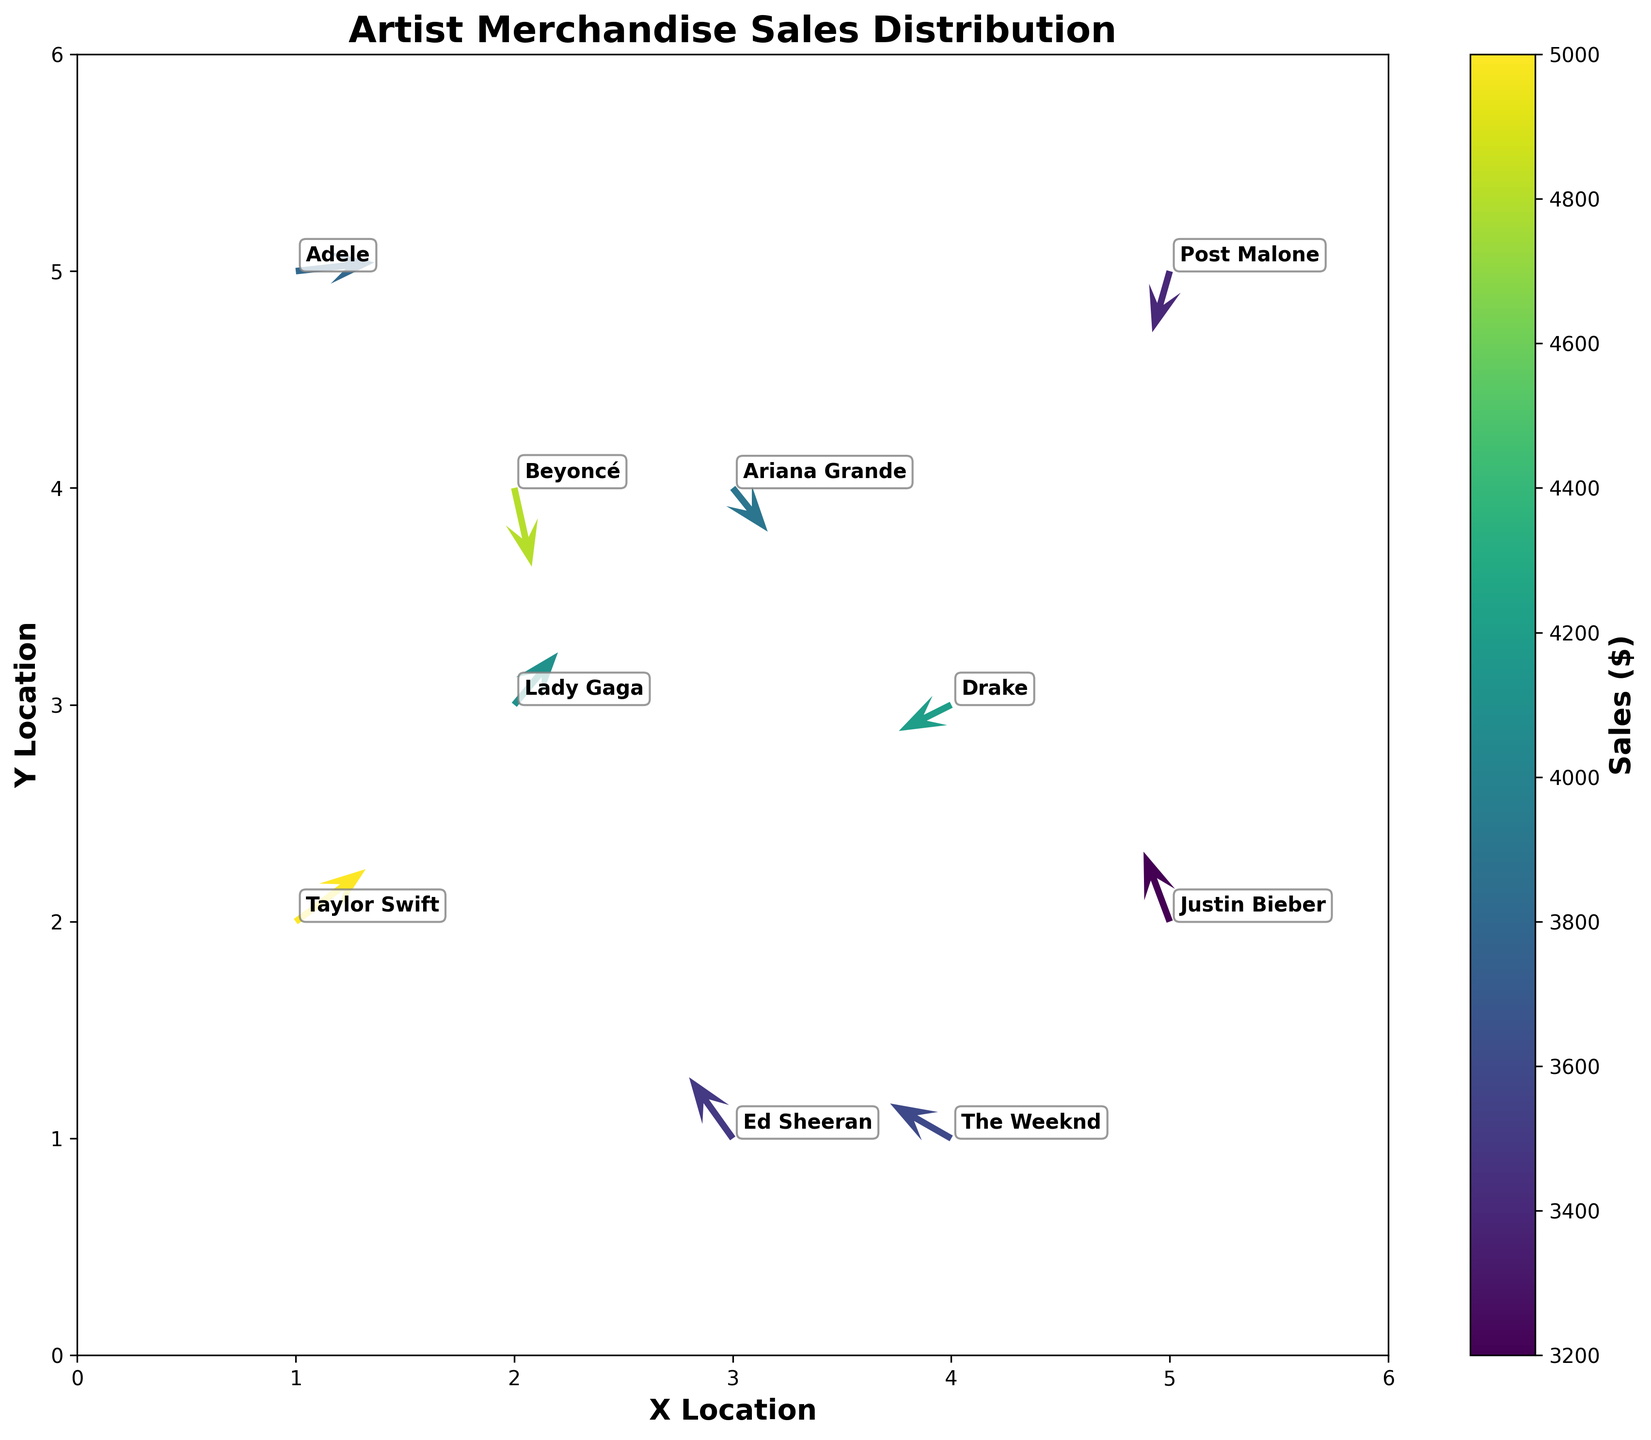What is the title of the figure? The title of the figure is typically located at the top and clearly labels the purpose or content of the plot. In this case, the title is "Artist Merchandise Sales Distribution".
Answer: Artist Merchandise Sales Distribution How many vendor locations are plotted in the figure? Each data point represents a vendor location, and the count of such points can be determined by counting the number of coordinates (x, y) in the plot.
Answer: 10 Which artist has the highest merchandise sales according to the figure? The color intensity in a Quiver Plot often indicates the magnitude of the represented variable. In this case, the artist with the highest merchandise sales will be associated with the most intense color. Taylor Swift in the dataset has the highest sales of $5,000.
Answer: Taylor Swift Which artist has the most upward direction in sales, based on the vector direction? The upward direction is indicated by the 'v' component of the vector being positive and relatively large. The artist with vector direction (u, v) clearly pointing upwards is Justin Bieber with a 'v' value of 0.8.
Answer: Justin Bieber Compare Taylor Swift's and Ed Sheeran's merchandise sales vector directions. Who has a stronger eastward component? The eastward component is represented by the 'u' value in the vector. Taylor Swift has a 'u' value of 0.8, while Ed Sheeran's 'u' value is -0.5. Therefore, Taylor Swift has a stronger eastward component.
Answer: Taylor Swift What is the combined merchandise sales of Beyoncé and Drake? By looking at the sales values for Beyoncé and Drake from the plot data, the sums are $4,800 and $4,200 respectively. Adding these together gives the combined sales. $4,800 + $4,200 = $9,000.
Answer: $9,000 How are vendors distributed across the x-y location space? By noting the scatter of the vector points, vendors appear to cover a broad area within the space defined by the axes from (0,0) to (6,6), showing a diverse location distribution.
Answer: Broad and diverse Which artist has a sales vector pointing predominantly southward? The southward direction is indicated by a highly negative 'v' component. Beyoncé has a 'v' value of -0.9, indicating a strong southward direction.
Answer: Beyoncé 